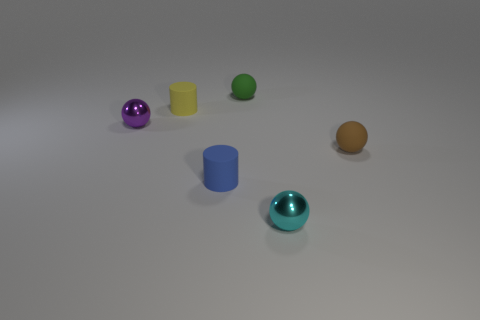How many tiny shiny things are in front of the small blue cylinder and on the left side of the small yellow cylinder?
Your response must be concise. 0. Is the number of rubber cylinders greater than the number of brown shiny blocks?
Your answer should be very brief. Yes. What is the yellow cylinder made of?
Offer a very short reply. Rubber. What number of tiny cyan shiny spheres are on the left side of the metal sphere that is left of the green thing?
Offer a very short reply. 0. What color is the metal sphere that is the same size as the cyan thing?
Your answer should be very brief. Purple. Is there another rubber object that has the same shape as the small brown object?
Your answer should be compact. Yes. Is the number of big green rubber cylinders less than the number of tiny green things?
Ensure brevity in your answer.  Yes. The tiny shiny object that is behind the cyan thing is what color?
Offer a very short reply. Purple. There is a tiny thing to the right of the small metal object on the right side of the yellow rubber thing; what is its shape?
Make the answer very short. Sphere. Does the purple object have the same material as the tiny object that is right of the cyan shiny thing?
Provide a succinct answer. No. 